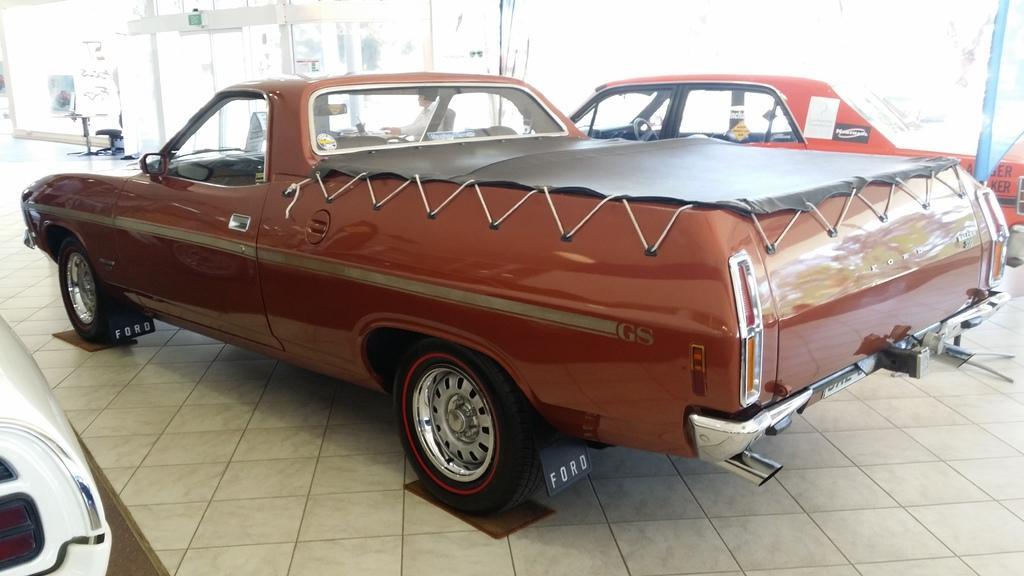How would you summarize this image in a sentence or two? In the image in the center we can see few vehicles. In the background we can see tables,chairs,banners,sign boards,one person sitting and few other objects. 